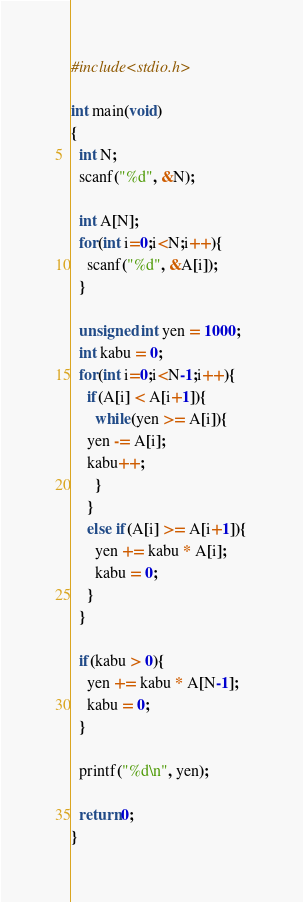Convert code to text. <code><loc_0><loc_0><loc_500><loc_500><_C_>#include<stdio.h>

int main(void)
{
  int N;
  scanf("%d", &N);

  int A[N];
  for(int i=0;i<N;i++){
    scanf("%d", &A[i]);
  }

  unsigned int yen = 1000;
  int kabu = 0;
  for(int i=0;i<N-1;i++){
    if(A[i] < A[i+1]){
      while(yen >= A[i]){
	yen -= A[i];
	kabu++;
      }
    }
    else if(A[i] >= A[i+1]){
      yen += kabu * A[i];
      kabu = 0;
    }
  }

  if(kabu > 0){
    yen += kabu * A[N-1];
    kabu = 0;
  }
  
  printf("%d\n", yen);

  return 0;
}
</code> 